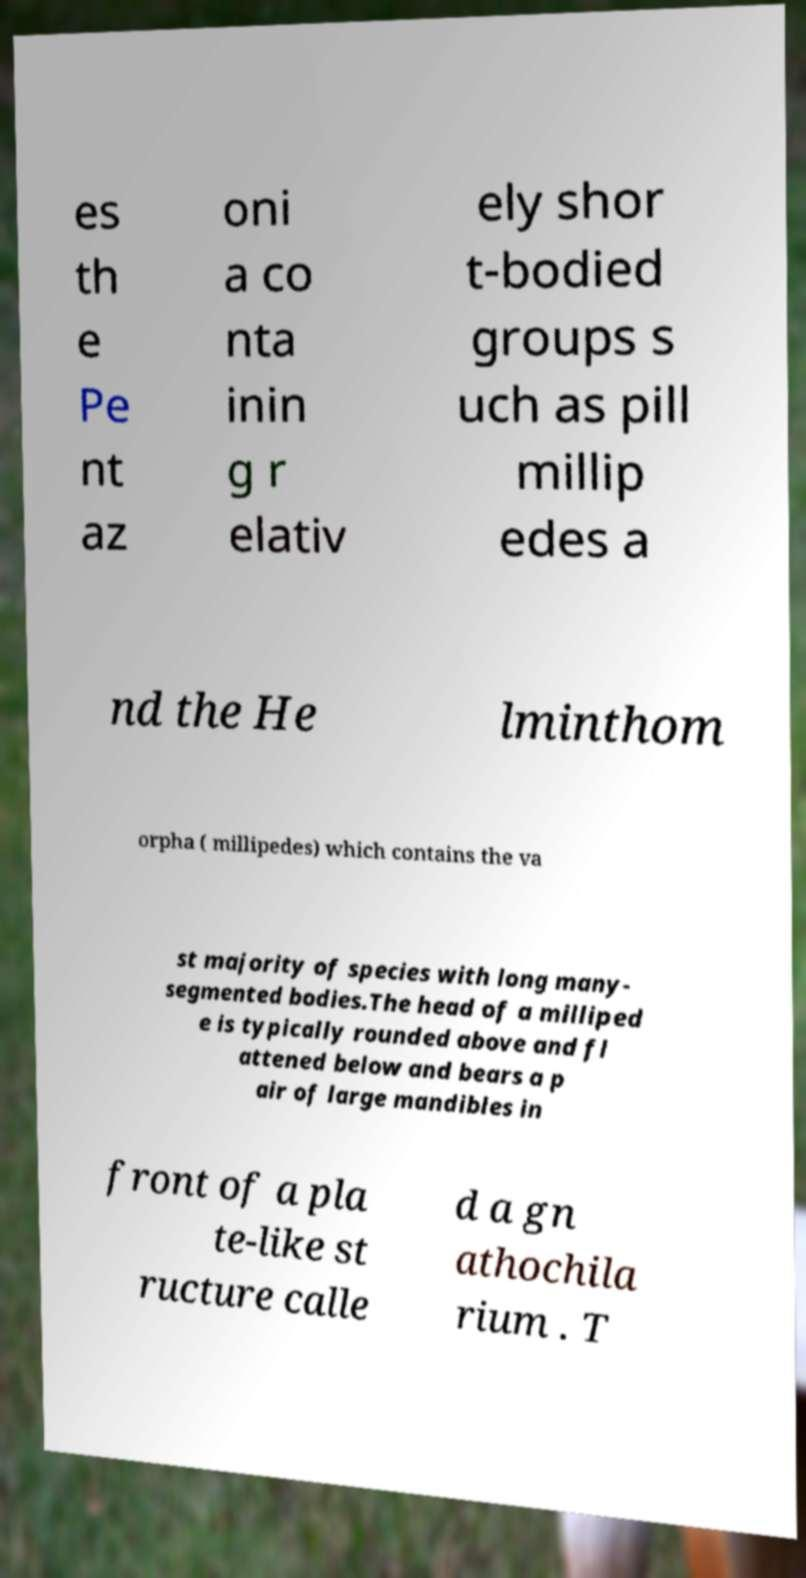Could you extract and type out the text from this image? es th e Pe nt az oni a co nta inin g r elativ ely shor t-bodied groups s uch as pill millip edes a nd the He lminthom orpha ( millipedes) which contains the va st majority of species with long many- segmented bodies.The head of a milliped e is typically rounded above and fl attened below and bears a p air of large mandibles in front of a pla te-like st ructure calle d a gn athochila rium . T 